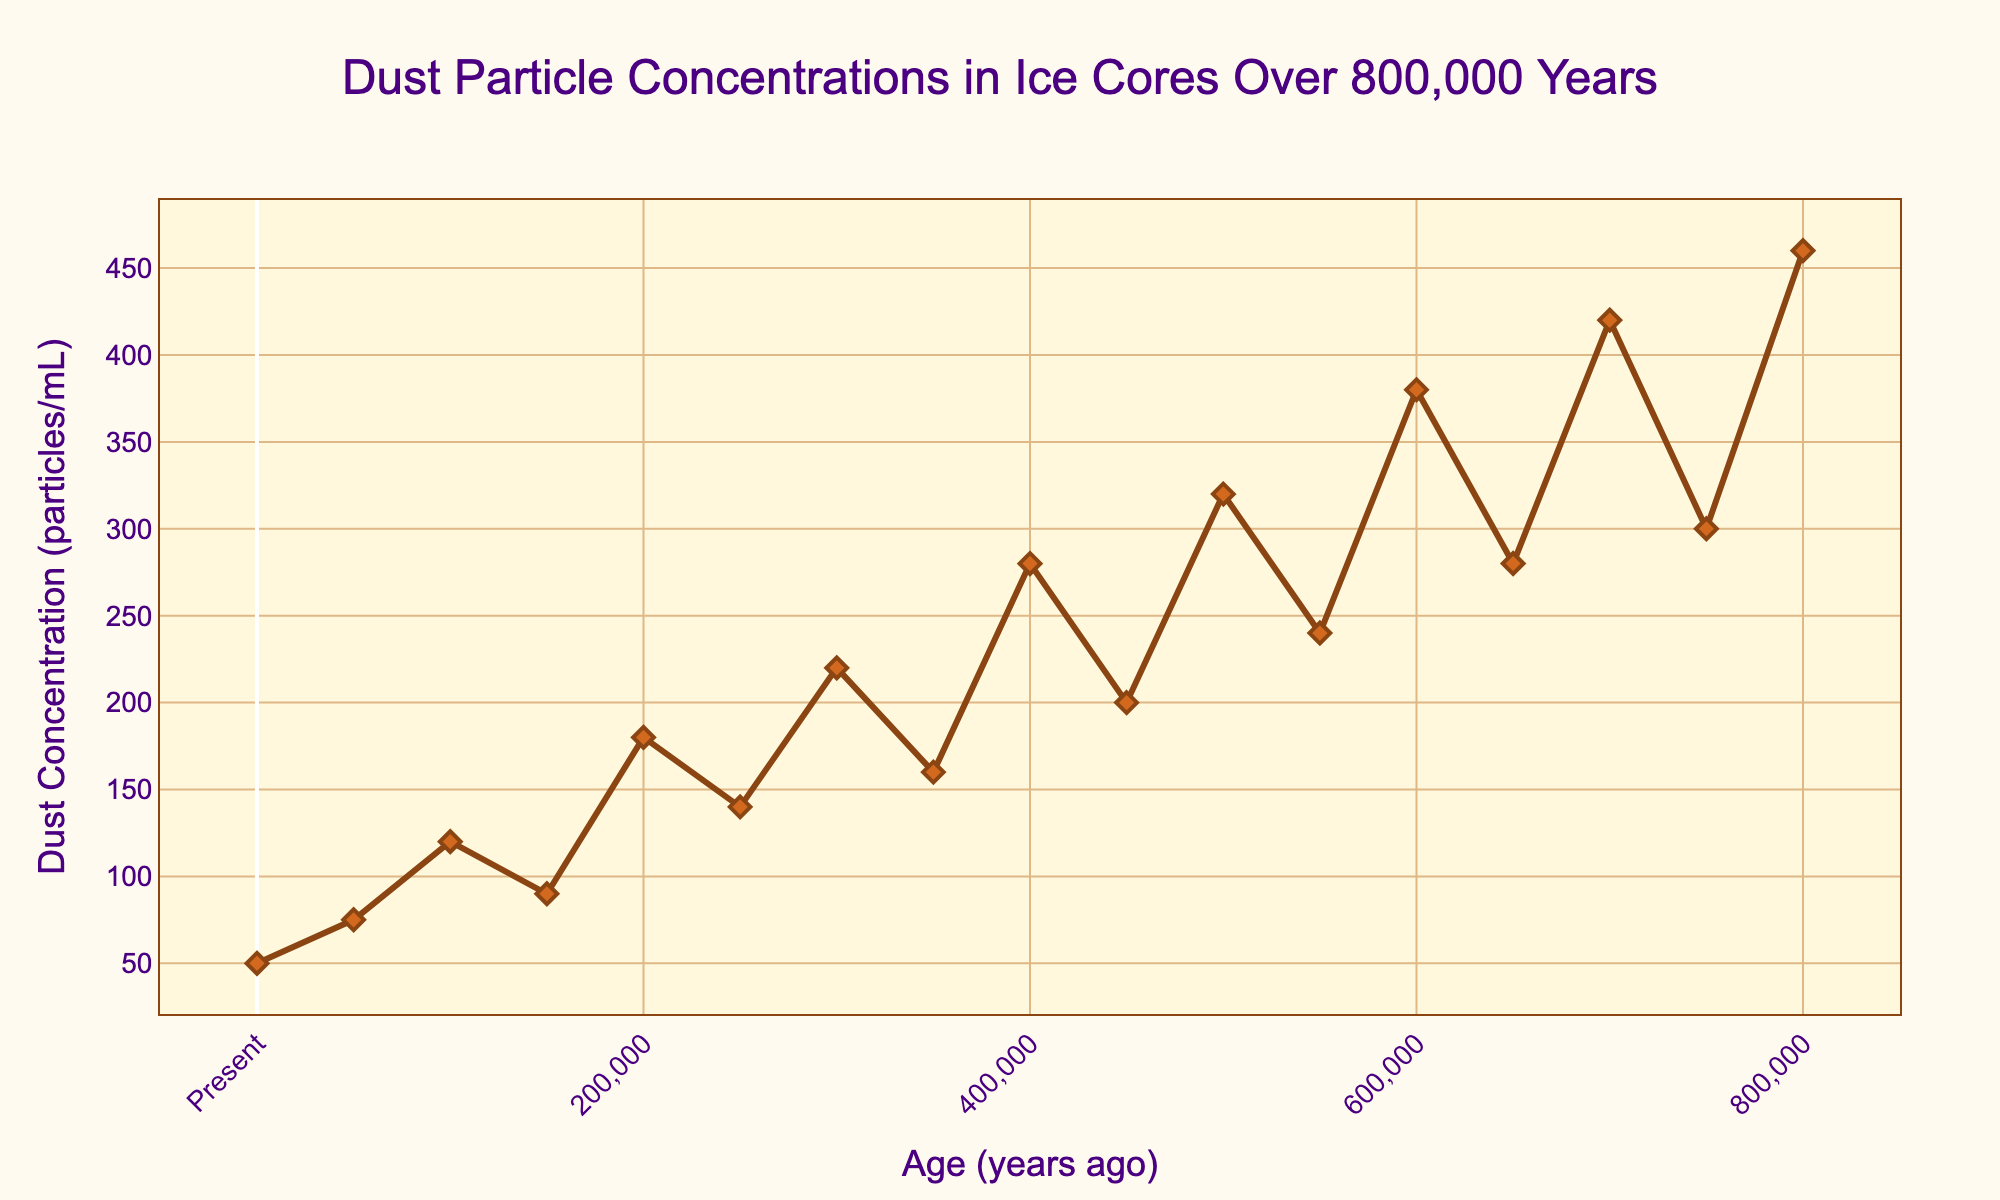What is the highest dust concentration observed in the last 800,000 years? The highest dust concentration can be found by examining the peak values on the y-axis of the plot. The maximum value is 460 particles/mL, occurring around 800,000 years ago.
Answer: 460 particles/mL When did the dust concentration reach its lowest point, and what was the concentration? By examining the plot, the lowest dust concentration is seen around the present time (0 years ago) with a value of 50 particles/mL.
Answer: Present, 50 particles/mL How much did the dust concentration increase between 600,000 and 500,000 years ago? The dust concentration at 600,000 years ago is 380 particles/mL, and at 500,000 years ago, it is 320 particles/mL. The increase is 380 - 320 = 60 particles/mL.
Answer: 60 particles/mL Which period experienced a higher dust concentration: 450,000 years ago or 750,000 years ago? By comparing the dust concentration values at 450,000 years ago (200 particles/mL) and 750,000 years ago (300 particles/mL), it is clear that 750,000 years ago had a higher dust concentration.
Answer: 750,000 years ago What is the average dust concentration between 300,000 and 400,000 years ago? To find the average, add the dust concentrations at 300,000 years ago (220 particles/mL) and 400,000 years ago (280 particles/mL), then divide by 2. The average is (220 + 280) / 2 = 250 particles/mL.
Answer: 250 particles/mL What trend in dust concentration can be observed around 650,000 years ago compared to 700,000 years ago? Comparing the values, the dust concentration at 650,000 years ago is 280 particles/mL, and at 700,000 years ago, it is 420 particles/mL. There is an increasing trend between these two points.
Answer: Increasing trend How many times did the dust concentration exceed 300 particles/mL? By scanning through the plot, dust concentration exceeds 300 particles/mL at four points: 700,000, 600,000, 500,000, and 400,000 years ago.
Answer: Four times Was there a greater increase in dust concentration between 200,000 and 300,000 years ago or between 400,000 and 500,000 years ago? The increase between 200,000 and 300,000 years ago: 220 - 180 = 40 particles/mL. Between 400,000 and 500,000 years ago: 320 - 280 = 40 particles/mL. Both periods had equal increases of 40 particles/mL.
Answer: Equal increases What is the change in dust concentration from the present to 50,000 years ago? The dust concentration at present is 50 particles/mL, and at 50,000 years ago, it is 75 particles/mL. The change is 75 - 50 = 25 particles/mL.
Answer: 25 particles/mL 